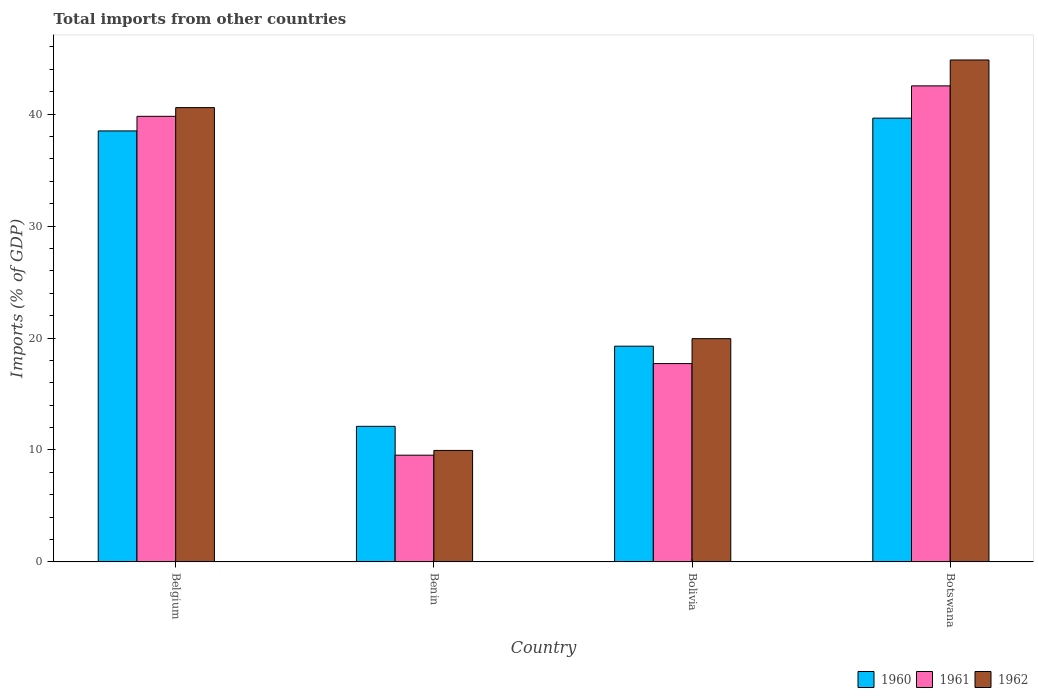How many groups of bars are there?
Offer a very short reply. 4. Are the number of bars per tick equal to the number of legend labels?
Ensure brevity in your answer.  Yes. Are the number of bars on each tick of the X-axis equal?
Ensure brevity in your answer.  Yes. What is the total imports in 1961 in Bolivia?
Provide a short and direct response. 17.72. Across all countries, what is the maximum total imports in 1962?
Provide a short and direct response. 44.84. Across all countries, what is the minimum total imports in 1960?
Your answer should be very brief. 12.11. In which country was the total imports in 1961 maximum?
Provide a succinct answer. Botswana. In which country was the total imports in 1961 minimum?
Provide a short and direct response. Benin. What is the total total imports in 1961 in the graph?
Your response must be concise. 109.58. What is the difference between the total imports in 1960 in Belgium and that in Benin?
Offer a terse response. 26.39. What is the difference between the total imports in 1961 in Benin and the total imports in 1962 in Bolivia?
Ensure brevity in your answer.  -10.41. What is the average total imports in 1961 per country?
Keep it short and to the point. 27.4. What is the difference between the total imports of/in 1961 and total imports of/in 1962 in Benin?
Your response must be concise. -0.42. What is the ratio of the total imports in 1960 in Belgium to that in Bolivia?
Provide a short and direct response. 2. Is the total imports in 1960 in Benin less than that in Botswana?
Keep it short and to the point. Yes. Is the difference between the total imports in 1961 in Belgium and Botswana greater than the difference between the total imports in 1962 in Belgium and Botswana?
Provide a succinct answer. Yes. What is the difference between the highest and the second highest total imports in 1961?
Offer a very short reply. -24.81. What is the difference between the highest and the lowest total imports in 1961?
Ensure brevity in your answer.  32.99. In how many countries, is the total imports in 1962 greater than the average total imports in 1962 taken over all countries?
Your response must be concise. 2. Is the sum of the total imports in 1962 in Benin and Bolivia greater than the maximum total imports in 1960 across all countries?
Give a very brief answer. No. What does the 3rd bar from the left in Belgium represents?
Your answer should be very brief. 1962. How many countries are there in the graph?
Keep it short and to the point. 4. What is the difference between two consecutive major ticks on the Y-axis?
Make the answer very short. 10. Are the values on the major ticks of Y-axis written in scientific E-notation?
Give a very brief answer. No. Does the graph contain any zero values?
Your answer should be compact. No. How are the legend labels stacked?
Give a very brief answer. Horizontal. What is the title of the graph?
Make the answer very short. Total imports from other countries. Does "2005" appear as one of the legend labels in the graph?
Offer a very short reply. No. What is the label or title of the Y-axis?
Offer a terse response. Imports (% of GDP). What is the Imports (% of GDP) in 1960 in Belgium?
Your answer should be compact. 38.5. What is the Imports (% of GDP) in 1961 in Belgium?
Provide a short and direct response. 39.81. What is the Imports (% of GDP) in 1962 in Belgium?
Your answer should be very brief. 40.58. What is the Imports (% of GDP) in 1960 in Benin?
Your answer should be compact. 12.11. What is the Imports (% of GDP) in 1961 in Benin?
Provide a short and direct response. 9.53. What is the Imports (% of GDP) in 1962 in Benin?
Your response must be concise. 9.96. What is the Imports (% of GDP) of 1960 in Bolivia?
Offer a terse response. 19.27. What is the Imports (% of GDP) of 1961 in Bolivia?
Offer a very short reply. 17.72. What is the Imports (% of GDP) of 1962 in Bolivia?
Your response must be concise. 19.94. What is the Imports (% of GDP) of 1960 in Botswana?
Keep it short and to the point. 39.64. What is the Imports (% of GDP) in 1961 in Botswana?
Provide a short and direct response. 42.53. What is the Imports (% of GDP) in 1962 in Botswana?
Keep it short and to the point. 44.84. Across all countries, what is the maximum Imports (% of GDP) of 1960?
Give a very brief answer. 39.64. Across all countries, what is the maximum Imports (% of GDP) in 1961?
Provide a short and direct response. 42.53. Across all countries, what is the maximum Imports (% of GDP) of 1962?
Keep it short and to the point. 44.84. Across all countries, what is the minimum Imports (% of GDP) in 1960?
Provide a succinct answer. 12.11. Across all countries, what is the minimum Imports (% of GDP) in 1961?
Your answer should be very brief. 9.53. Across all countries, what is the minimum Imports (% of GDP) of 1962?
Offer a very short reply. 9.96. What is the total Imports (% of GDP) of 1960 in the graph?
Make the answer very short. 109.53. What is the total Imports (% of GDP) of 1961 in the graph?
Your answer should be compact. 109.58. What is the total Imports (% of GDP) of 1962 in the graph?
Keep it short and to the point. 115.33. What is the difference between the Imports (% of GDP) of 1960 in Belgium and that in Benin?
Keep it short and to the point. 26.39. What is the difference between the Imports (% of GDP) in 1961 in Belgium and that in Benin?
Keep it short and to the point. 30.27. What is the difference between the Imports (% of GDP) in 1962 in Belgium and that in Benin?
Ensure brevity in your answer.  30.63. What is the difference between the Imports (% of GDP) in 1960 in Belgium and that in Bolivia?
Offer a very short reply. 19.23. What is the difference between the Imports (% of GDP) of 1961 in Belgium and that in Bolivia?
Your response must be concise. 22.09. What is the difference between the Imports (% of GDP) in 1962 in Belgium and that in Bolivia?
Ensure brevity in your answer.  20.64. What is the difference between the Imports (% of GDP) of 1960 in Belgium and that in Botswana?
Offer a terse response. -1.14. What is the difference between the Imports (% of GDP) in 1961 in Belgium and that in Botswana?
Keep it short and to the point. -2.72. What is the difference between the Imports (% of GDP) in 1962 in Belgium and that in Botswana?
Offer a terse response. -4.25. What is the difference between the Imports (% of GDP) of 1960 in Benin and that in Bolivia?
Provide a short and direct response. -7.16. What is the difference between the Imports (% of GDP) of 1961 in Benin and that in Bolivia?
Your response must be concise. -8.18. What is the difference between the Imports (% of GDP) of 1962 in Benin and that in Bolivia?
Offer a very short reply. -9.98. What is the difference between the Imports (% of GDP) of 1960 in Benin and that in Botswana?
Your response must be concise. -27.53. What is the difference between the Imports (% of GDP) in 1961 in Benin and that in Botswana?
Give a very brief answer. -32.99. What is the difference between the Imports (% of GDP) in 1962 in Benin and that in Botswana?
Your answer should be very brief. -34.88. What is the difference between the Imports (% of GDP) in 1960 in Bolivia and that in Botswana?
Make the answer very short. -20.37. What is the difference between the Imports (% of GDP) in 1961 in Bolivia and that in Botswana?
Ensure brevity in your answer.  -24.81. What is the difference between the Imports (% of GDP) in 1962 in Bolivia and that in Botswana?
Your response must be concise. -24.9. What is the difference between the Imports (% of GDP) of 1960 in Belgium and the Imports (% of GDP) of 1961 in Benin?
Give a very brief answer. 28.97. What is the difference between the Imports (% of GDP) in 1960 in Belgium and the Imports (% of GDP) in 1962 in Benin?
Ensure brevity in your answer.  28.54. What is the difference between the Imports (% of GDP) in 1961 in Belgium and the Imports (% of GDP) in 1962 in Benin?
Ensure brevity in your answer.  29.85. What is the difference between the Imports (% of GDP) of 1960 in Belgium and the Imports (% of GDP) of 1961 in Bolivia?
Offer a terse response. 20.78. What is the difference between the Imports (% of GDP) in 1960 in Belgium and the Imports (% of GDP) in 1962 in Bolivia?
Ensure brevity in your answer.  18.56. What is the difference between the Imports (% of GDP) of 1961 in Belgium and the Imports (% of GDP) of 1962 in Bolivia?
Give a very brief answer. 19.86. What is the difference between the Imports (% of GDP) in 1960 in Belgium and the Imports (% of GDP) in 1961 in Botswana?
Ensure brevity in your answer.  -4.02. What is the difference between the Imports (% of GDP) in 1960 in Belgium and the Imports (% of GDP) in 1962 in Botswana?
Make the answer very short. -6.34. What is the difference between the Imports (% of GDP) of 1961 in Belgium and the Imports (% of GDP) of 1962 in Botswana?
Make the answer very short. -5.03. What is the difference between the Imports (% of GDP) of 1960 in Benin and the Imports (% of GDP) of 1961 in Bolivia?
Give a very brief answer. -5.61. What is the difference between the Imports (% of GDP) of 1960 in Benin and the Imports (% of GDP) of 1962 in Bolivia?
Provide a succinct answer. -7.83. What is the difference between the Imports (% of GDP) in 1961 in Benin and the Imports (% of GDP) in 1962 in Bolivia?
Offer a very short reply. -10.41. What is the difference between the Imports (% of GDP) in 1960 in Benin and the Imports (% of GDP) in 1961 in Botswana?
Provide a short and direct response. -30.42. What is the difference between the Imports (% of GDP) of 1960 in Benin and the Imports (% of GDP) of 1962 in Botswana?
Provide a short and direct response. -32.73. What is the difference between the Imports (% of GDP) in 1961 in Benin and the Imports (% of GDP) in 1962 in Botswana?
Your answer should be compact. -35.3. What is the difference between the Imports (% of GDP) of 1960 in Bolivia and the Imports (% of GDP) of 1961 in Botswana?
Provide a short and direct response. -23.25. What is the difference between the Imports (% of GDP) in 1960 in Bolivia and the Imports (% of GDP) in 1962 in Botswana?
Give a very brief answer. -25.57. What is the difference between the Imports (% of GDP) in 1961 in Bolivia and the Imports (% of GDP) in 1962 in Botswana?
Provide a succinct answer. -27.12. What is the average Imports (% of GDP) of 1960 per country?
Your response must be concise. 27.38. What is the average Imports (% of GDP) in 1961 per country?
Make the answer very short. 27.4. What is the average Imports (% of GDP) in 1962 per country?
Keep it short and to the point. 28.83. What is the difference between the Imports (% of GDP) in 1960 and Imports (% of GDP) in 1961 in Belgium?
Give a very brief answer. -1.3. What is the difference between the Imports (% of GDP) in 1960 and Imports (% of GDP) in 1962 in Belgium?
Ensure brevity in your answer.  -2.08. What is the difference between the Imports (% of GDP) in 1961 and Imports (% of GDP) in 1962 in Belgium?
Provide a short and direct response. -0.78. What is the difference between the Imports (% of GDP) of 1960 and Imports (% of GDP) of 1961 in Benin?
Your answer should be compact. 2.58. What is the difference between the Imports (% of GDP) in 1960 and Imports (% of GDP) in 1962 in Benin?
Offer a terse response. 2.15. What is the difference between the Imports (% of GDP) in 1961 and Imports (% of GDP) in 1962 in Benin?
Give a very brief answer. -0.42. What is the difference between the Imports (% of GDP) in 1960 and Imports (% of GDP) in 1961 in Bolivia?
Keep it short and to the point. 1.55. What is the difference between the Imports (% of GDP) of 1960 and Imports (% of GDP) of 1962 in Bolivia?
Provide a short and direct response. -0.67. What is the difference between the Imports (% of GDP) of 1961 and Imports (% of GDP) of 1962 in Bolivia?
Your response must be concise. -2.23. What is the difference between the Imports (% of GDP) in 1960 and Imports (% of GDP) in 1961 in Botswana?
Provide a succinct answer. -2.88. What is the difference between the Imports (% of GDP) of 1960 and Imports (% of GDP) of 1962 in Botswana?
Ensure brevity in your answer.  -5.2. What is the difference between the Imports (% of GDP) in 1961 and Imports (% of GDP) in 1962 in Botswana?
Make the answer very short. -2.31. What is the ratio of the Imports (% of GDP) of 1960 in Belgium to that in Benin?
Your answer should be compact. 3.18. What is the ratio of the Imports (% of GDP) of 1961 in Belgium to that in Benin?
Your answer should be very brief. 4.17. What is the ratio of the Imports (% of GDP) of 1962 in Belgium to that in Benin?
Your answer should be compact. 4.08. What is the ratio of the Imports (% of GDP) in 1960 in Belgium to that in Bolivia?
Keep it short and to the point. 2. What is the ratio of the Imports (% of GDP) of 1961 in Belgium to that in Bolivia?
Offer a terse response. 2.25. What is the ratio of the Imports (% of GDP) of 1962 in Belgium to that in Bolivia?
Give a very brief answer. 2.04. What is the ratio of the Imports (% of GDP) in 1960 in Belgium to that in Botswana?
Your answer should be very brief. 0.97. What is the ratio of the Imports (% of GDP) of 1961 in Belgium to that in Botswana?
Give a very brief answer. 0.94. What is the ratio of the Imports (% of GDP) in 1962 in Belgium to that in Botswana?
Give a very brief answer. 0.91. What is the ratio of the Imports (% of GDP) in 1960 in Benin to that in Bolivia?
Keep it short and to the point. 0.63. What is the ratio of the Imports (% of GDP) of 1961 in Benin to that in Bolivia?
Provide a short and direct response. 0.54. What is the ratio of the Imports (% of GDP) in 1962 in Benin to that in Bolivia?
Make the answer very short. 0.5. What is the ratio of the Imports (% of GDP) of 1960 in Benin to that in Botswana?
Your answer should be compact. 0.31. What is the ratio of the Imports (% of GDP) of 1961 in Benin to that in Botswana?
Offer a very short reply. 0.22. What is the ratio of the Imports (% of GDP) of 1962 in Benin to that in Botswana?
Make the answer very short. 0.22. What is the ratio of the Imports (% of GDP) of 1960 in Bolivia to that in Botswana?
Make the answer very short. 0.49. What is the ratio of the Imports (% of GDP) of 1961 in Bolivia to that in Botswana?
Ensure brevity in your answer.  0.42. What is the ratio of the Imports (% of GDP) of 1962 in Bolivia to that in Botswana?
Offer a very short reply. 0.44. What is the difference between the highest and the second highest Imports (% of GDP) of 1960?
Provide a short and direct response. 1.14. What is the difference between the highest and the second highest Imports (% of GDP) of 1961?
Provide a succinct answer. 2.72. What is the difference between the highest and the second highest Imports (% of GDP) in 1962?
Keep it short and to the point. 4.25. What is the difference between the highest and the lowest Imports (% of GDP) in 1960?
Offer a very short reply. 27.53. What is the difference between the highest and the lowest Imports (% of GDP) of 1961?
Give a very brief answer. 32.99. What is the difference between the highest and the lowest Imports (% of GDP) of 1962?
Keep it short and to the point. 34.88. 